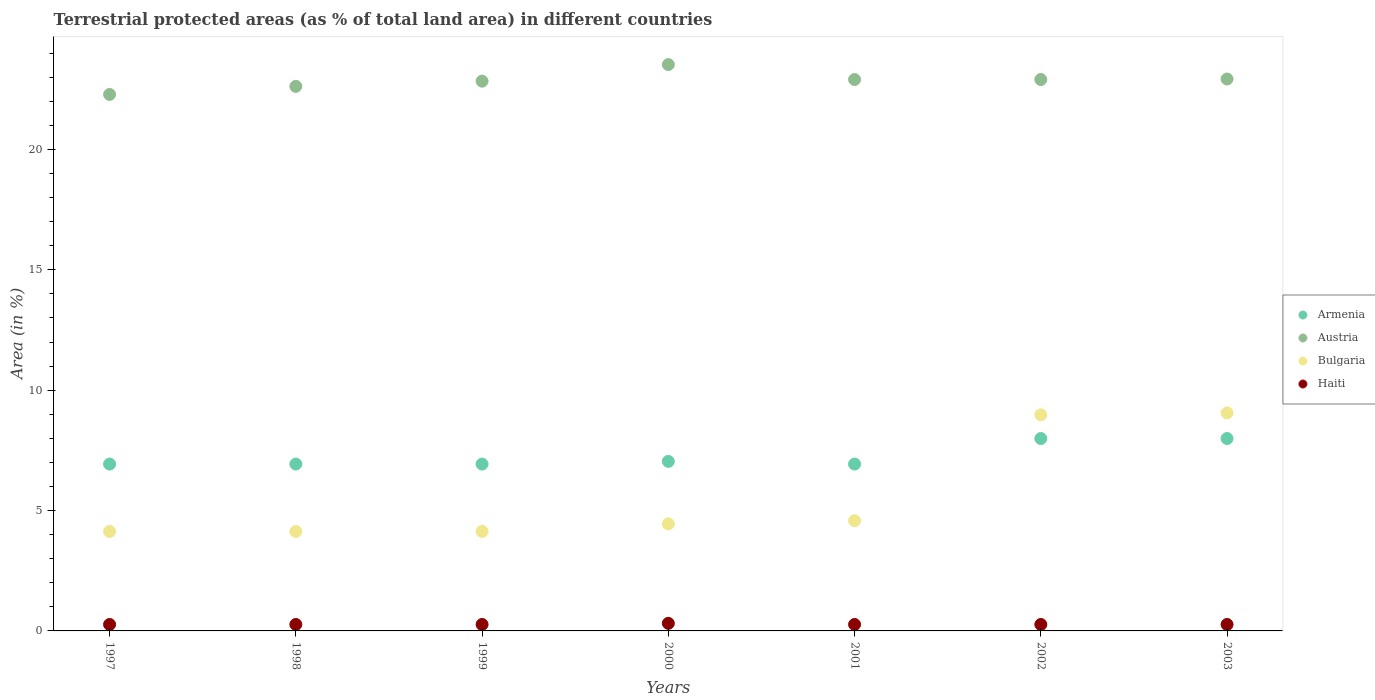What is the percentage of terrestrial protected land in Haiti in 1998?
Offer a very short reply. 0.27. Across all years, what is the maximum percentage of terrestrial protected land in Austria?
Provide a succinct answer. 23.52. Across all years, what is the minimum percentage of terrestrial protected land in Bulgaria?
Keep it short and to the point. 4.13. What is the total percentage of terrestrial protected land in Bulgaria in the graph?
Your answer should be very brief. 39.45. What is the difference between the percentage of terrestrial protected land in Bulgaria in 2000 and that in 2001?
Keep it short and to the point. -0.13. What is the difference between the percentage of terrestrial protected land in Bulgaria in 2002 and the percentage of terrestrial protected land in Armenia in 2000?
Offer a very short reply. 1.93. What is the average percentage of terrestrial protected land in Bulgaria per year?
Offer a very short reply. 5.64. In the year 2002, what is the difference between the percentage of terrestrial protected land in Haiti and percentage of terrestrial protected land in Bulgaria?
Offer a very short reply. -8.71. What is the ratio of the percentage of terrestrial protected land in Armenia in 2001 to that in 2003?
Keep it short and to the point. 0.87. What is the difference between the highest and the second highest percentage of terrestrial protected land in Bulgaria?
Make the answer very short. 0.08. What is the difference between the highest and the lowest percentage of terrestrial protected land in Armenia?
Make the answer very short. 1.06. Is it the case that in every year, the sum of the percentage of terrestrial protected land in Bulgaria and percentage of terrestrial protected land in Haiti  is greater than the sum of percentage of terrestrial protected land in Austria and percentage of terrestrial protected land in Armenia?
Keep it short and to the point. No. Does the percentage of terrestrial protected land in Bulgaria monotonically increase over the years?
Your answer should be very brief. No. Is the percentage of terrestrial protected land in Bulgaria strictly less than the percentage of terrestrial protected land in Austria over the years?
Your answer should be compact. Yes. How many years are there in the graph?
Your answer should be very brief. 7. Are the values on the major ticks of Y-axis written in scientific E-notation?
Give a very brief answer. No. Does the graph contain any zero values?
Provide a short and direct response. No. Does the graph contain grids?
Keep it short and to the point. No. Where does the legend appear in the graph?
Provide a succinct answer. Center right. What is the title of the graph?
Give a very brief answer. Terrestrial protected areas (as % of total land area) in different countries. What is the label or title of the Y-axis?
Offer a very short reply. Area (in %). What is the Area (in %) of Armenia in 1997?
Keep it short and to the point. 6.93. What is the Area (in %) of Austria in 1997?
Make the answer very short. 22.28. What is the Area (in %) of Bulgaria in 1997?
Your answer should be compact. 4.13. What is the Area (in %) in Haiti in 1997?
Make the answer very short. 0.27. What is the Area (in %) of Armenia in 1998?
Your answer should be very brief. 6.93. What is the Area (in %) in Austria in 1998?
Make the answer very short. 22.62. What is the Area (in %) of Bulgaria in 1998?
Your response must be concise. 4.13. What is the Area (in %) in Haiti in 1998?
Your response must be concise. 0.27. What is the Area (in %) of Armenia in 1999?
Your response must be concise. 6.93. What is the Area (in %) of Austria in 1999?
Your answer should be compact. 22.84. What is the Area (in %) of Bulgaria in 1999?
Your answer should be very brief. 4.13. What is the Area (in %) of Haiti in 1999?
Offer a very short reply. 0.27. What is the Area (in %) in Armenia in 2000?
Give a very brief answer. 7.04. What is the Area (in %) in Austria in 2000?
Give a very brief answer. 23.52. What is the Area (in %) of Bulgaria in 2000?
Give a very brief answer. 4.45. What is the Area (in %) in Haiti in 2000?
Your answer should be compact. 0.32. What is the Area (in %) in Armenia in 2001?
Provide a succinct answer. 6.93. What is the Area (in %) of Austria in 2001?
Keep it short and to the point. 22.9. What is the Area (in %) in Bulgaria in 2001?
Your answer should be compact. 4.58. What is the Area (in %) in Haiti in 2001?
Your answer should be compact. 0.27. What is the Area (in %) of Armenia in 2002?
Ensure brevity in your answer.  7.99. What is the Area (in %) of Austria in 2002?
Make the answer very short. 22.9. What is the Area (in %) in Bulgaria in 2002?
Your answer should be very brief. 8.97. What is the Area (in %) of Haiti in 2002?
Offer a terse response. 0.27. What is the Area (in %) of Armenia in 2003?
Give a very brief answer. 7.99. What is the Area (in %) of Austria in 2003?
Your answer should be very brief. 22.92. What is the Area (in %) of Bulgaria in 2003?
Your response must be concise. 9.06. What is the Area (in %) of Haiti in 2003?
Offer a terse response. 0.27. Across all years, what is the maximum Area (in %) of Armenia?
Keep it short and to the point. 7.99. Across all years, what is the maximum Area (in %) of Austria?
Give a very brief answer. 23.52. Across all years, what is the maximum Area (in %) of Bulgaria?
Provide a short and direct response. 9.06. Across all years, what is the maximum Area (in %) of Haiti?
Ensure brevity in your answer.  0.32. Across all years, what is the minimum Area (in %) of Armenia?
Your answer should be compact. 6.93. Across all years, what is the minimum Area (in %) in Austria?
Your answer should be very brief. 22.28. Across all years, what is the minimum Area (in %) in Bulgaria?
Provide a short and direct response. 4.13. Across all years, what is the minimum Area (in %) of Haiti?
Provide a succinct answer. 0.27. What is the total Area (in %) of Armenia in the graph?
Make the answer very short. 50.75. What is the total Area (in %) in Austria in the graph?
Offer a very short reply. 160. What is the total Area (in %) of Bulgaria in the graph?
Your answer should be very brief. 39.45. What is the total Area (in %) in Haiti in the graph?
Your answer should be very brief. 1.92. What is the difference between the Area (in %) in Armenia in 1997 and that in 1998?
Give a very brief answer. 0. What is the difference between the Area (in %) of Austria in 1997 and that in 1998?
Provide a short and direct response. -0.33. What is the difference between the Area (in %) in Haiti in 1997 and that in 1998?
Offer a very short reply. 0. What is the difference between the Area (in %) of Austria in 1997 and that in 1999?
Provide a succinct answer. -0.55. What is the difference between the Area (in %) in Bulgaria in 1997 and that in 1999?
Your answer should be very brief. -0. What is the difference between the Area (in %) of Haiti in 1997 and that in 1999?
Provide a succinct answer. 0. What is the difference between the Area (in %) in Armenia in 1997 and that in 2000?
Ensure brevity in your answer.  -0.11. What is the difference between the Area (in %) of Austria in 1997 and that in 2000?
Offer a terse response. -1.24. What is the difference between the Area (in %) of Bulgaria in 1997 and that in 2000?
Keep it short and to the point. -0.32. What is the difference between the Area (in %) of Haiti in 1997 and that in 2000?
Provide a succinct answer. -0.05. What is the difference between the Area (in %) in Austria in 1997 and that in 2001?
Offer a terse response. -0.62. What is the difference between the Area (in %) in Bulgaria in 1997 and that in 2001?
Offer a terse response. -0.45. What is the difference between the Area (in %) in Armenia in 1997 and that in 2002?
Your response must be concise. -1.06. What is the difference between the Area (in %) of Austria in 1997 and that in 2002?
Offer a very short reply. -0.62. What is the difference between the Area (in %) in Bulgaria in 1997 and that in 2002?
Your answer should be very brief. -4.84. What is the difference between the Area (in %) in Armenia in 1997 and that in 2003?
Offer a terse response. -1.06. What is the difference between the Area (in %) in Austria in 1997 and that in 2003?
Make the answer very short. -0.64. What is the difference between the Area (in %) in Bulgaria in 1997 and that in 2003?
Provide a short and direct response. -4.92. What is the difference between the Area (in %) in Armenia in 1998 and that in 1999?
Provide a short and direct response. 0. What is the difference between the Area (in %) of Austria in 1998 and that in 1999?
Your answer should be compact. -0.22. What is the difference between the Area (in %) in Bulgaria in 1998 and that in 1999?
Your answer should be very brief. -0. What is the difference between the Area (in %) in Haiti in 1998 and that in 1999?
Your response must be concise. 0. What is the difference between the Area (in %) of Armenia in 1998 and that in 2000?
Your answer should be very brief. -0.11. What is the difference between the Area (in %) of Austria in 1998 and that in 2000?
Ensure brevity in your answer.  -0.91. What is the difference between the Area (in %) of Bulgaria in 1998 and that in 2000?
Keep it short and to the point. -0.32. What is the difference between the Area (in %) in Haiti in 1998 and that in 2000?
Give a very brief answer. -0.05. What is the difference between the Area (in %) of Armenia in 1998 and that in 2001?
Provide a succinct answer. 0. What is the difference between the Area (in %) in Austria in 1998 and that in 2001?
Offer a terse response. -0.29. What is the difference between the Area (in %) in Bulgaria in 1998 and that in 2001?
Your answer should be very brief. -0.45. What is the difference between the Area (in %) of Armenia in 1998 and that in 2002?
Provide a succinct answer. -1.06. What is the difference between the Area (in %) of Austria in 1998 and that in 2002?
Keep it short and to the point. -0.29. What is the difference between the Area (in %) in Bulgaria in 1998 and that in 2002?
Give a very brief answer. -4.84. What is the difference between the Area (in %) in Haiti in 1998 and that in 2002?
Ensure brevity in your answer.  0. What is the difference between the Area (in %) of Armenia in 1998 and that in 2003?
Your answer should be compact. -1.06. What is the difference between the Area (in %) of Austria in 1998 and that in 2003?
Make the answer very short. -0.31. What is the difference between the Area (in %) in Bulgaria in 1998 and that in 2003?
Your response must be concise. -4.92. What is the difference between the Area (in %) of Haiti in 1998 and that in 2003?
Provide a succinct answer. 0. What is the difference between the Area (in %) of Armenia in 1999 and that in 2000?
Offer a very short reply. -0.11. What is the difference between the Area (in %) of Austria in 1999 and that in 2000?
Offer a terse response. -0.69. What is the difference between the Area (in %) of Bulgaria in 1999 and that in 2000?
Ensure brevity in your answer.  -0.31. What is the difference between the Area (in %) of Haiti in 1999 and that in 2000?
Make the answer very short. -0.05. What is the difference between the Area (in %) in Armenia in 1999 and that in 2001?
Give a very brief answer. 0. What is the difference between the Area (in %) in Austria in 1999 and that in 2001?
Ensure brevity in your answer.  -0.07. What is the difference between the Area (in %) of Bulgaria in 1999 and that in 2001?
Provide a short and direct response. -0.44. What is the difference between the Area (in %) in Haiti in 1999 and that in 2001?
Ensure brevity in your answer.  0. What is the difference between the Area (in %) of Armenia in 1999 and that in 2002?
Offer a terse response. -1.06. What is the difference between the Area (in %) of Austria in 1999 and that in 2002?
Keep it short and to the point. -0.07. What is the difference between the Area (in %) of Bulgaria in 1999 and that in 2002?
Ensure brevity in your answer.  -4.84. What is the difference between the Area (in %) of Haiti in 1999 and that in 2002?
Your answer should be very brief. 0. What is the difference between the Area (in %) of Armenia in 1999 and that in 2003?
Keep it short and to the point. -1.06. What is the difference between the Area (in %) in Austria in 1999 and that in 2003?
Keep it short and to the point. -0.09. What is the difference between the Area (in %) of Bulgaria in 1999 and that in 2003?
Keep it short and to the point. -4.92. What is the difference between the Area (in %) of Haiti in 1999 and that in 2003?
Your answer should be compact. 0. What is the difference between the Area (in %) in Armenia in 2000 and that in 2001?
Provide a short and direct response. 0.11. What is the difference between the Area (in %) in Austria in 2000 and that in 2001?
Give a very brief answer. 0.62. What is the difference between the Area (in %) in Bulgaria in 2000 and that in 2001?
Your response must be concise. -0.13. What is the difference between the Area (in %) in Haiti in 2000 and that in 2001?
Offer a terse response. 0.05. What is the difference between the Area (in %) in Armenia in 2000 and that in 2002?
Ensure brevity in your answer.  -0.95. What is the difference between the Area (in %) in Austria in 2000 and that in 2002?
Keep it short and to the point. 0.62. What is the difference between the Area (in %) in Bulgaria in 2000 and that in 2002?
Make the answer very short. -4.53. What is the difference between the Area (in %) of Haiti in 2000 and that in 2002?
Keep it short and to the point. 0.05. What is the difference between the Area (in %) in Armenia in 2000 and that in 2003?
Provide a short and direct response. -0.95. What is the difference between the Area (in %) in Austria in 2000 and that in 2003?
Give a very brief answer. 0.6. What is the difference between the Area (in %) of Bulgaria in 2000 and that in 2003?
Give a very brief answer. -4.61. What is the difference between the Area (in %) in Haiti in 2000 and that in 2003?
Give a very brief answer. 0.05. What is the difference between the Area (in %) of Armenia in 2001 and that in 2002?
Your answer should be compact. -1.06. What is the difference between the Area (in %) in Austria in 2001 and that in 2002?
Your response must be concise. -0. What is the difference between the Area (in %) of Bulgaria in 2001 and that in 2002?
Offer a very short reply. -4.4. What is the difference between the Area (in %) of Armenia in 2001 and that in 2003?
Your response must be concise. -1.06. What is the difference between the Area (in %) of Austria in 2001 and that in 2003?
Your answer should be compact. -0.02. What is the difference between the Area (in %) of Bulgaria in 2001 and that in 2003?
Keep it short and to the point. -4.48. What is the difference between the Area (in %) in Austria in 2002 and that in 2003?
Provide a succinct answer. -0.02. What is the difference between the Area (in %) of Bulgaria in 2002 and that in 2003?
Your answer should be very brief. -0.08. What is the difference between the Area (in %) in Armenia in 1997 and the Area (in %) in Austria in 1998?
Keep it short and to the point. -15.69. What is the difference between the Area (in %) of Armenia in 1997 and the Area (in %) of Bulgaria in 1998?
Keep it short and to the point. 2.8. What is the difference between the Area (in %) in Armenia in 1997 and the Area (in %) in Haiti in 1998?
Ensure brevity in your answer.  6.66. What is the difference between the Area (in %) of Austria in 1997 and the Area (in %) of Bulgaria in 1998?
Ensure brevity in your answer.  18.15. What is the difference between the Area (in %) in Austria in 1997 and the Area (in %) in Haiti in 1998?
Your answer should be compact. 22.02. What is the difference between the Area (in %) in Bulgaria in 1997 and the Area (in %) in Haiti in 1998?
Your answer should be very brief. 3.86. What is the difference between the Area (in %) of Armenia in 1997 and the Area (in %) of Austria in 1999?
Make the answer very short. -15.9. What is the difference between the Area (in %) of Armenia in 1997 and the Area (in %) of Bulgaria in 1999?
Keep it short and to the point. 2.8. What is the difference between the Area (in %) of Armenia in 1997 and the Area (in %) of Haiti in 1999?
Your answer should be very brief. 6.66. What is the difference between the Area (in %) in Austria in 1997 and the Area (in %) in Bulgaria in 1999?
Offer a very short reply. 18.15. What is the difference between the Area (in %) of Austria in 1997 and the Area (in %) of Haiti in 1999?
Provide a succinct answer. 22.02. What is the difference between the Area (in %) of Bulgaria in 1997 and the Area (in %) of Haiti in 1999?
Your answer should be very brief. 3.86. What is the difference between the Area (in %) of Armenia in 1997 and the Area (in %) of Austria in 2000?
Your answer should be very brief. -16.59. What is the difference between the Area (in %) in Armenia in 1997 and the Area (in %) in Bulgaria in 2000?
Your answer should be compact. 2.48. What is the difference between the Area (in %) in Armenia in 1997 and the Area (in %) in Haiti in 2000?
Ensure brevity in your answer.  6.62. What is the difference between the Area (in %) in Austria in 1997 and the Area (in %) in Bulgaria in 2000?
Give a very brief answer. 17.84. What is the difference between the Area (in %) of Austria in 1997 and the Area (in %) of Haiti in 2000?
Give a very brief answer. 21.97. What is the difference between the Area (in %) of Bulgaria in 1997 and the Area (in %) of Haiti in 2000?
Your answer should be very brief. 3.82. What is the difference between the Area (in %) in Armenia in 1997 and the Area (in %) in Austria in 2001?
Give a very brief answer. -15.97. What is the difference between the Area (in %) of Armenia in 1997 and the Area (in %) of Bulgaria in 2001?
Give a very brief answer. 2.35. What is the difference between the Area (in %) in Armenia in 1997 and the Area (in %) in Haiti in 2001?
Make the answer very short. 6.66. What is the difference between the Area (in %) in Austria in 1997 and the Area (in %) in Bulgaria in 2001?
Your answer should be compact. 17.71. What is the difference between the Area (in %) in Austria in 1997 and the Area (in %) in Haiti in 2001?
Provide a succinct answer. 22.02. What is the difference between the Area (in %) of Bulgaria in 1997 and the Area (in %) of Haiti in 2001?
Your answer should be compact. 3.86. What is the difference between the Area (in %) in Armenia in 1997 and the Area (in %) in Austria in 2002?
Offer a terse response. -15.97. What is the difference between the Area (in %) of Armenia in 1997 and the Area (in %) of Bulgaria in 2002?
Offer a terse response. -2.04. What is the difference between the Area (in %) in Armenia in 1997 and the Area (in %) in Haiti in 2002?
Your answer should be very brief. 6.66. What is the difference between the Area (in %) in Austria in 1997 and the Area (in %) in Bulgaria in 2002?
Provide a succinct answer. 13.31. What is the difference between the Area (in %) in Austria in 1997 and the Area (in %) in Haiti in 2002?
Ensure brevity in your answer.  22.02. What is the difference between the Area (in %) in Bulgaria in 1997 and the Area (in %) in Haiti in 2002?
Provide a succinct answer. 3.86. What is the difference between the Area (in %) of Armenia in 1997 and the Area (in %) of Austria in 2003?
Make the answer very short. -15.99. What is the difference between the Area (in %) of Armenia in 1997 and the Area (in %) of Bulgaria in 2003?
Your answer should be compact. -2.12. What is the difference between the Area (in %) of Armenia in 1997 and the Area (in %) of Haiti in 2003?
Ensure brevity in your answer.  6.66. What is the difference between the Area (in %) in Austria in 1997 and the Area (in %) in Bulgaria in 2003?
Make the answer very short. 13.23. What is the difference between the Area (in %) in Austria in 1997 and the Area (in %) in Haiti in 2003?
Provide a short and direct response. 22.02. What is the difference between the Area (in %) in Bulgaria in 1997 and the Area (in %) in Haiti in 2003?
Offer a terse response. 3.86. What is the difference between the Area (in %) of Armenia in 1998 and the Area (in %) of Austria in 1999?
Provide a succinct answer. -15.9. What is the difference between the Area (in %) in Armenia in 1998 and the Area (in %) in Bulgaria in 1999?
Give a very brief answer. 2.8. What is the difference between the Area (in %) in Armenia in 1998 and the Area (in %) in Haiti in 1999?
Offer a terse response. 6.66. What is the difference between the Area (in %) in Austria in 1998 and the Area (in %) in Bulgaria in 1999?
Make the answer very short. 18.49. What is the difference between the Area (in %) of Austria in 1998 and the Area (in %) of Haiti in 1999?
Offer a terse response. 22.35. What is the difference between the Area (in %) in Bulgaria in 1998 and the Area (in %) in Haiti in 1999?
Provide a short and direct response. 3.86. What is the difference between the Area (in %) in Armenia in 1998 and the Area (in %) in Austria in 2000?
Your answer should be compact. -16.59. What is the difference between the Area (in %) in Armenia in 1998 and the Area (in %) in Bulgaria in 2000?
Your response must be concise. 2.48. What is the difference between the Area (in %) in Armenia in 1998 and the Area (in %) in Haiti in 2000?
Offer a very short reply. 6.62. What is the difference between the Area (in %) in Austria in 1998 and the Area (in %) in Bulgaria in 2000?
Keep it short and to the point. 18.17. What is the difference between the Area (in %) of Austria in 1998 and the Area (in %) of Haiti in 2000?
Provide a short and direct response. 22.3. What is the difference between the Area (in %) of Bulgaria in 1998 and the Area (in %) of Haiti in 2000?
Give a very brief answer. 3.82. What is the difference between the Area (in %) in Armenia in 1998 and the Area (in %) in Austria in 2001?
Give a very brief answer. -15.97. What is the difference between the Area (in %) of Armenia in 1998 and the Area (in %) of Bulgaria in 2001?
Your response must be concise. 2.35. What is the difference between the Area (in %) of Armenia in 1998 and the Area (in %) of Haiti in 2001?
Your answer should be compact. 6.66. What is the difference between the Area (in %) of Austria in 1998 and the Area (in %) of Bulgaria in 2001?
Provide a succinct answer. 18.04. What is the difference between the Area (in %) in Austria in 1998 and the Area (in %) in Haiti in 2001?
Provide a short and direct response. 22.35. What is the difference between the Area (in %) in Bulgaria in 1998 and the Area (in %) in Haiti in 2001?
Offer a very short reply. 3.86. What is the difference between the Area (in %) of Armenia in 1998 and the Area (in %) of Austria in 2002?
Provide a succinct answer. -15.97. What is the difference between the Area (in %) in Armenia in 1998 and the Area (in %) in Bulgaria in 2002?
Give a very brief answer. -2.04. What is the difference between the Area (in %) in Armenia in 1998 and the Area (in %) in Haiti in 2002?
Offer a terse response. 6.66. What is the difference between the Area (in %) in Austria in 1998 and the Area (in %) in Bulgaria in 2002?
Your answer should be very brief. 13.64. What is the difference between the Area (in %) in Austria in 1998 and the Area (in %) in Haiti in 2002?
Offer a terse response. 22.35. What is the difference between the Area (in %) in Bulgaria in 1998 and the Area (in %) in Haiti in 2002?
Offer a terse response. 3.86. What is the difference between the Area (in %) of Armenia in 1998 and the Area (in %) of Austria in 2003?
Your response must be concise. -15.99. What is the difference between the Area (in %) in Armenia in 1998 and the Area (in %) in Bulgaria in 2003?
Offer a very short reply. -2.12. What is the difference between the Area (in %) in Armenia in 1998 and the Area (in %) in Haiti in 2003?
Offer a terse response. 6.66. What is the difference between the Area (in %) of Austria in 1998 and the Area (in %) of Bulgaria in 2003?
Your answer should be very brief. 13.56. What is the difference between the Area (in %) of Austria in 1998 and the Area (in %) of Haiti in 2003?
Your answer should be compact. 22.35. What is the difference between the Area (in %) of Bulgaria in 1998 and the Area (in %) of Haiti in 2003?
Ensure brevity in your answer.  3.86. What is the difference between the Area (in %) of Armenia in 1999 and the Area (in %) of Austria in 2000?
Your answer should be very brief. -16.59. What is the difference between the Area (in %) in Armenia in 1999 and the Area (in %) in Bulgaria in 2000?
Offer a very short reply. 2.48. What is the difference between the Area (in %) in Armenia in 1999 and the Area (in %) in Haiti in 2000?
Ensure brevity in your answer.  6.62. What is the difference between the Area (in %) in Austria in 1999 and the Area (in %) in Bulgaria in 2000?
Offer a terse response. 18.39. What is the difference between the Area (in %) in Austria in 1999 and the Area (in %) in Haiti in 2000?
Ensure brevity in your answer.  22.52. What is the difference between the Area (in %) in Bulgaria in 1999 and the Area (in %) in Haiti in 2000?
Offer a very short reply. 3.82. What is the difference between the Area (in %) of Armenia in 1999 and the Area (in %) of Austria in 2001?
Your answer should be compact. -15.97. What is the difference between the Area (in %) of Armenia in 1999 and the Area (in %) of Bulgaria in 2001?
Provide a succinct answer. 2.35. What is the difference between the Area (in %) of Armenia in 1999 and the Area (in %) of Haiti in 2001?
Offer a very short reply. 6.66. What is the difference between the Area (in %) in Austria in 1999 and the Area (in %) in Bulgaria in 2001?
Make the answer very short. 18.26. What is the difference between the Area (in %) in Austria in 1999 and the Area (in %) in Haiti in 2001?
Make the answer very short. 22.57. What is the difference between the Area (in %) of Bulgaria in 1999 and the Area (in %) of Haiti in 2001?
Your answer should be very brief. 3.86. What is the difference between the Area (in %) of Armenia in 1999 and the Area (in %) of Austria in 2002?
Keep it short and to the point. -15.97. What is the difference between the Area (in %) in Armenia in 1999 and the Area (in %) in Bulgaria in 2002?
Provide a short and direct response. -2.04. What is the difference between the Area (in %) of Armenia in 1999 and the Area (in %) of Haiti in 2002?
Keep it short and to the point. 6.66. What is the difference between the Area (in %) of Austria in 1999 and the Area (in %) of Bulgaria in 2002?
Provide a succinct answer. 13.86. What is the difference between the Area (in %) in Austria in 1999 and the Area (in %) in Haiti in 2002?
Keep it short and to the point. 22.57. What is the difference between the Area (in %) in Bulgaria in 1999 and the Area (in %) in Haiti in 2002?
Offer a terse response. 3.86. What is the difference between the Area (in %) in Armenia in 1999 and the Area (in %) in Austria in 2003?
Your answer should be compact. -15.99. What is the difference between the Area (in %) in Armenia in 1999 and the Area (in %) in Bulgaria in 2003?
Offer a very short reply. -2.12. What is the difference between the Area (in %) in Armenia in 1999 and the Area (in %) in Haiti in 2003?
Offer a terse response. 6.66. What is the difference between the Area (in %) in Austria in 1999 and the Area (in %) in Bulgaria in 2003?
Ensure brevity in your answer.  13.78. What is the difference between the Area (in %) in Austria in 1999 and the Area (in %) in Haiti in 2003?
Your answer should be very brief. 22.57. What is the difference between the Area (in %) of Bulgaria in 1999 and the Area (in %) of Haiti in 2003?
Offer a very short reply. 3.86. What is the difference between the Area (in %) in Armenia in 2000 and the Area (in %) in Austria in 2001?
Give a very brief answer. -15.86. What is the difference between the Area (in %) of Armenia in 2000 and the Area (in %) of Bulgaria in 2001?
Ensure brevity in your answer.  2.47. What is the difference between the Area (in %) of Armenia in 2000 and the Area (in %) of Haiti in 2001?
Your answer should be compact. 6.77. What is the difference between the Area (in %) in Austria in 2000 and the Area (in %) in Bulgaria in 2001?
Offer a terse response. 18.95. What is the difference between the Area (in %) of Austria in 2000 and the Area (in %) of Haiti in 2001?
Ensure brevity in your answer.  23.26. What is the difference between the Area (in %) in Bulgaria in 2000 and the Area (in %) in Haiti in 2001?
Provide a short and direct response. 4.18. What is the difference between the Area (in %) of Armenia in 2000 and the Area (in %) of Austria in 2002?
Your response must be concise. -15.86. What is the difference between the Area (in %) of Armenia in 2000 and the Area (in %) of Bulgaria in 2002?
Keep it short and to the point. -1.93. What is the difference between the Area (in %) in Armenia in 2000 and the Area (in %) in Haiti in 2002?
Offer a terse response. 6.77. What is the difference between the Area (in %) of Austria in 2000 and the Area (in %) of Bulgaria in 2002?
Keep it short and to the point. 14.55. What is the difference between the Area (in %) of Austria in 2000 and the Area (in %) of Haiti in 2002?
Make the answer very short. 23.26. What is the difference between the Area (in %) of Bulgaria in 2000 and the Area (in %) of Haiti in 2002?
Make the answer very short. 4.18. What is the difference between the Area (in %) of Armenia in 2000 and the Area (in %) of Austria in 2003?
Ensure brevity in your answer.  -15.88. What is the difference between the Area (in %) of Armenia in 2000 and the Area (in %) of Bulgaria in 2003?
Give a very brief answer. -2.01. What is the difference between the Area (in %) of Armenia in 2000 and the Area (in %) of Haiti in 2003?
Your response must be concise. 6.77. What is the difference between the Area (in %) in Austria in 2000 and the Area (in %) in Bulgaria in 2003?
Offer a terse response. 14.47. What is the difference between the Area (in %) of Austria in 2000 and the Area (in %) of Haiti in 2003?
Ensure brevity in your answer.  23.26. What is the difference between the Area (in %) of Bulgaria in 2000 and the Area (in %) of Haiti in 2003?
Your response must be concise. 4.18. What is the difference between the Area (in %) in Armenia in 2001 and the Area (in %) in Austria in 2002?
Provide a short and direct response. -15.97. What is the difference between the Area (in %) in Armenia in 2001 and the Area (in %) in Bulgaria in 2002?
Provide a short and direct response. -2.04. What is the difference between the Area (in %) in Armenia in 2001 and the Area (in %) in Haiti in 2002?
Provide a short and direct response. 6.66. What is the difference between the Area (in %) in Austria in 2001 and the Area (in %) in Bulgaria in 2002?
Your answer should be compact. 13.93. What is the difference between the Area (in %) in Austria in 2001 and the Area (in %) in Haiti in 2002?
Your answer should be very brief. 22.64. What is the difference between the Area (in %) in Bulgaria in 2001 and the Area (in %) in Haiti in 2002?
Your response must be concise. 4.31. What is the difference between the Area (in %) in Armenia in 2001 and the Area (in %) in Austria in 2003?
Offer a very short reply. -15.99. What is the difference between the Area (in %) of Armenia in 2001 and the Area (in %) of Bulgaria in 2003?
Give a very brief answer. -2.12. What is the difference between the Area (in %) in Armenia in 2001 and the Area (in %) in Haiti in 2003?
Make the answer very short. 6.66. What is the difference between the Area (in %) of Austria in 2001 and the Area (in %) of Bulgaria in 2003?
Ensure brevity in your answer.  13.85. What is the difference between the Area (in %) in Austria in 2001 and the Area (in %) in Haiti in 2003?
Offer a terse response. 22.64. What is the difference between the Area (in %) of Bulgaria in 2001 and the Area (in %) of Haiti in 2003?
Give a very brief answer. 4.31. What is the difference between the Area (in %) in Armenia in 2002 and the Area (in %) in Austria in 2003?
Your answer should be compact. -14.93. What is the difference between the Area (in %) of Armenia in 2002 and the Area (in %) of Bulgaria in 2003?
Offer a very short reply. -1.06. What is the difference between the Area (in %) in Armenia in 2002 and the Area (in %) in Haiti in 2003?
Offer a very short reply. 7.72. What is the difference between the Area (in %) in Austria in 2002 and the Area (in %) in Bulgaria in 2003?
Keep it short and to the point. 13.85. What is the difference between the Area (in %) of Austria in 2002 and the Area (in %) of Haiti in 2003?
Provide a short and direct response. 22.64. What is the difference between the Area (in %) in Bulgaria in 2002 and the Area (in %) in Haiti in 2003?
Ensure brevity in your answer.  8.71. What is the average Area (in %) of Armenia per year?
Keep it short and to the point. 7.25. What is the average Area (in %) in Austria per year?
Give a very brief answer. 22.86. What is the average Area (in %) of Bulgaria per year?
Make the answer very short. 5.64. What is the average Area (in %) in Haiti per year?
Give a very brief answer. 0.27. In the year 1997, what is the difference between the Area (in %) of Armenia and Area (in %) of Austria?
Make the answer very short. -15.35. In the year 1997, what is the difference between the Area (in %) in Armenia and Area (in %) in Bulgaria?
Your response must be concise. 2.8. In the year 1997, what is the difference between the Area (in %) in Armenia and Area (in %) in Haiti?
Ensure brevity in your answer.  6.66. In the year 1997, what is the difference between the Area (in %) in Austria and Area (in %) in Bulgaria?
Your answer should be compact. 18.15. In the year 1997, what is the difference between the Area (in %) of Austria and Area (in %) of Haiti?
Your answer should be compact. 22.02. In the year 1997, what is the difference between the Area (in %) of Bulgaria and Area (in %) of Haiti?
Offer a very short reply. 3.86. In the year 1998, what is the difference between the Area (in %) in Armenia and Area (in %) in Austria?
Keep it short and to the point. -15.69. In the year 1998, what is the difference between the Area (in %) of Armenia and Area (in %) of Bulgaria?
Give a very brief answer. 2.8. In the year 1998, what is the difference between the Area (in %) of Armenia and Area (in %) of Haiti?
Provide a succinct answer. 6.66. In the year 1998, what is the difference between the Area (in %) in Austria and Area (in %) in Bulgaria?
Provide a short and direct response. 18.49. In the year 1998, what is the difference between the Area (in %) in Austria and Area (in %) in Haiti?
Offer a terse response. 22.35. In the year 1998, what is the difference between the Area (in %) in Bulgaria and Area (in %) in Haiti?
Your answer should be very brief. 3.86. In the year 1999, what is the difference between the Area (in %) in Armenia and Area (in %) in Austria?
Your response must be concise. -15.9. In the year 1999, what is the difference between the Area (in %) in Armenia and Area (in %) in Bulgaria?
Offer a terse response. 2.8. In the year 1999, what is the difference between the Area (in %) of Armenia and Area (in %) of Haiti?
Provide a succinct answer. 6.66. In the year 1999, what is the difference between the Area (in %) in Austria and Area (in %) in Bulgaria?
Offer a terse response. 18.7. In the year 1999, what is the difference between the Area (in %) in Austria and Area (in %) in Haiti?
Offer a terse response. 22.57. In the year 1999, what is the difference between the Area (in %) of Bulgaria and Area (in %) of Haiti?
Your answer should be compact. 3.86. In the year 2000, what is the difference between the Area (in %) in Armenia and Area (in %) in Austria?
Make the answer very short. -16.48. In the year 2000, what is the difference between the Area (in %) in Armenia and Area (in %) in Bulgaria?
Ensure brevity in your answer.  2.6. In the year 2000, what is the difference between the Area (in %) of Armenia and Area (in %) of Haiti?
Provide a succinct answer. 6.73. In the year 2000, what is the difference between the Area (in %) of Austria and Area (in %) of Bulgaria?
Provide a short and direct response. 19.08. In the year 2000, what is the difference between the Area (in %) of Austria and Area (in %) of Haiti?
Provide a succinct answer. 23.21. In the year 2000, what is the difference between the Area (in %) of Bulgaria and Area (in %) of Haiti?
Offer a very short reply. 4.13. In the year 2001, what is the difference between the Area (in %) of Armenia and Area (in %) of Austria?
Your answer should be very brief. -15.97. In the year 2001, what is the difference between the Area (in %) in Armenia and Area (in %) in Bulgaria?
Provide a succinct answer. 2.35. In the year 2001, what is the difference between the Area (in %) in Armenia and Area (in %) in Haiti?
Your answer should be compact. 6.66. In the year 2001, what is the difference between the Area (in %) in Austria and Area (in %) in Bulgaria?
Provide a succinct answer. 18.33. In the year 2001, what is the difference between the Area (in %) in Austria and Area (in %) in Haiti?
Keep it short and to the point. 22.64. In the year 2001, what is the difference between the Area (in %) in Bulgaria and Area (in %) in Haiti?
Your response must be concise. 4.31. In the year 2002, what is the difference between the Area (in %) in Armenia and Area (in %) in Austria?
Your answer should be compact. -14.91. In the year 2002, what is the difference between the Area (in %) in Armenia and Area (in %) in Bulgaria?
Your answer should be compact. -0.98. In the year 2002, what is the difference between the Area (in %) of Armenia and Area (in %) of Haiti?
Ensure brevity in your answer.  7.72. In the year 2002, what is the difference between the Area (in %) of Austria and Area (in %) of Bulgaria?
Make the answer very short. 13.93. In the year 2002, what is the difference between the Area (in %) of Austria and Area (in %) of Haiti?
Your answer should be compact. 22.64. In the year 2002, what is the difference between the Area (in %) in Bulgaria and Area (in %) in Haiti?
Provide a succinct answer. 8.71. In the year 2003, what is the difference between the Area (in %) of Armenia and Area (in %) of Austria?
Provide a short and direct response. -14.93. In the year 2003, what is the difference between the Area (in %) in Armenia and Area (in %) in Bulgaria?
Your response must be concise. -1.06. In the year 2003, what is the difference between the Area (in %) of Armenia and Area (in %) of Haiti?
Offer a terse response. 7.72. In the year 2003, what is the difference between the Area (in %) of Austria and Area (in %) of Bulgaria?
Your answer should be compact. 13.87. In the year 2003, what is the difference between the Area (in %) of Austria and Area (in %) of Haiti?
Make the answer very short. 22.66. In the year 2003, what is the difference between the Area (in %) in Bulgaria and Area (in %) in Haiti?
Keep it short and to the point. 8.79. What is the ratio of the Area (in %) in Armenia in 1997 to that in 1998?
Offer a very short reply. 1. What is the ratio of the Area (in %) in Austria in 1997 to that in 1998?
Provide a short and direct response. 0.99. What is the ratio of the Area (in %) in Armenia in 1997 to that in 1999?
Ensure brevity in your answer.  1. What is the ratio of the Area (in %) of Austria in 1997 to that in 1999?
Your answer should be compact. 0.98. What is the ratio of the Area (in %) in Bulgaria in 1997 to that in 1999?
Your answer should be very brief. 1. What is the ratio of the Area (in %) in Armenia in 1997 to that in 2000?
Make the answer very short. 0.98. What is the ratio of the Area (in %) in Austria in 1997 to that in 2000?
Give a very brief answer. 0.95. What is the ratio of the Area (in %) in Bulgaria in 1997 to that in 2000?
Offer a very short reply. 0.93. What is the ratio of the Area (in %) of Haiti in 1997 to that in 2000?
Give a very brief answer. 0.85. What is the ratio of the Area (in %) in Armenia in 1997 to that in 2001?
Your answer should be compact. 1. What is the ratio of the Area (in %) of Austria in 1997 to that in 2001?
Give a very brief answer. 0.97. What is the ratio of the Area (in %) of Bulgaria in 1997 to that in 2001?
Keep it short and to the point. 0.9. What is the ratio of the Area (in %) of Haiti in 1997 to that in 2001?
Ensure brevity in your answer.  1. What is the ratio of the Area (in %) in Armenia in 1997 to that in 2002?
Your response must be concise. 0.87. What is the ratio of the Area (in %) of Austria in 1997 to that in 2002?
Your response must be concise. 0.97. What is the ratio of the Area (in %) of Bulgaria in 1997 to that in 2002?
Offer a terse response. 0.46. What is the ratio of the Area (in %) in Haiti in 1997 to that in 2002?
Ensure brevity in your answer.  1. What is the ratio of the Area (in %) in Armenia in 1997 to that in 2003?
Make the answer very short. 0.87. What is the ratio of the Area (in %) in Austria in 1997 to that in 2003?
Make the answer very short. 0.97. What is the ratio of the Area (in %) in Bulgaria in 1997 to that in 2003?
Make the answer very short. 0.46. What is the ratio of the Area (in %) of Austria in 1998 to that in 1999?
Ensure brevity in your answer.  0.99. What is the ratio of the Area (in %) in Bulgaria in 1998 to that in 1999?
Make the answer very short. 1. What is the ratio of the Area (in %) in Armenia in 1998 to that in 2000?
Ensure brevity in your answer.  0.98. What is the ratio of the Area (in %) of Austria in 1998 to that in 2000?
Provide a short and direct response. 0.96. What is the ratio of the Area (in %) in Bulgaria in 1998 to that in 2000?
Provide a short and direct response. 0.93. What is the ratio of the Area (in %) in Haiti in 1998 to that in 2000?
Give a very brief answer. 0.85. What is the ratio of the Area (in %) of Armenia in 1998 to that in 2001?
Your answer should be very brief. 1. What is the ratio of the Area (in %) of Austria in 1998 to that in 2001?
Offer a very short reply. 0.99. What is the ratio of the Area (in %) in Bulgaria in 1998 to that in 2001?
Provide a short and direct response. 0.9. What is the ratio of the Area (in %) in Armenia in 1998 to that in 2002?
Your response must be concise. 0.87. What is the ratio of the Area (in %) of Austria in 1998 to that in 2002?
Offer a very short reply. 0.99. What is the ratio of the Area (in %) of Bulgaria in 1998 to that in 2002?
Ensure brevity in your answer.  0.46. What is the ratio of the Area (in %) of Armenia in 1998 to that in 2003?
Provide a short and direct response. 0.87. What is the ratio of the Area (in %) of Austria in 1998 to that in 2003?
Provide a succinct answer. 0.99. What is the ratio of the Area (in %) of Bulgaria in 1998 to that in 2003?
Provide a short and direct response. 0.46. What is the ratio of the Area (in %) in Haiti in 1998 to that in 2003?
Offer a very short reply. 1. What is the ratio of the Area (in %) in Armenia in 1999 to that in 2000?
Offer a terse response. 0.98. What is the ratio of the Area (in %) in Austria in 1999 to that in 2000?
Your answer should be very brief. 0.97. What is the ratio of the Area (in %) in Bulgaria in 1999 to that in 2000?
Provide a short and direct response. 0.93. What is the ratio of the Area (in %) of Haiti in 1999 to that in 2000?
Offer a very short reply. 0.85. What is the ratio of the Area (in %) in Armenia in 1999 to that in 2001?
Your answer should be very brief. 1. What is the ratio of the Area (in %) in Bulgaria in 1999 to that in 2001?
Offer a terse response. 0.9. What is the ratio of the Area (in %) in Haiti in 1999 to that in 2001?
Make the answer very short. 1. What is the ratio of the Area (in %) of Armenia in 1999 to that in 2002?
Provide a succinct answer. 0.87. What is the ratio of the Area (in %) of Austria in 1999 to that in 2002?
Keep it short and to the point. 1. What is the ratio of the Area (in %) in Bulgaria in 1999 to that in 2002?
Your response must be concise. 0.46. What is the ratio of the Area (in %) in Armenia in 1999 to that in 2003?
Give a very brief answer. 0.87. What is the ratio of the Area (in %) of Austria in 1999 to that in 2003?
Ensure brevity in your answer.  1. What is the ratio of the Area (in %) in Bulgaria in 1999 to that in 2003?
Your answer should be very brief. 0.46. What is the ratio of the Area (in %) of Austria in 2000 to that in 2001?
Offer a very short reply. 1.03. What is the ratio of the Area (in %) in Bulgaria in 2000 to that in 2001?
Keep it short and to the point. 0.97. What is the ratio of the Area (in %) of Haiti in 2000 to that in 2001?
Make the answer very short. 1.18. What is the ratio of the Area (in %) in Armenia in 2000 to that in 2002?
Keep it short and to the point. 0.88. What is the ratio of the Area (in %) of Austria in 2000 to that in 2002?
Your answer should be very brief. 1.03. What is the ratio of the Area (in %) of Bulgaria in 2000 to that in 2002?
Give a very brief answer. 0.5. What is the ratio of the Area (in %) in Haiti in 2000 to that in 2002?
Offer a very short reply. 1.18. What is the ratio of the Area (in %) in Armenia in 2000 to that in 2003?
Make the answer very short. 0.88. What is the ratio of the Area (in %) of Austria in 2000 to that in 2003?
Make the answer very short. 1.03. What is the ratio of the Area (in %) of Bulgaria in 2000 to that in 2003?
Offer a terse response. 0.49. What is the ratio of the Area (in %) of Haiti in 2000 to that in 2003?
Make the answer very short. 1.18. What is the ratio of the Area (in %) in Armenia in 2001 to that in 2002?
Provide a succinct answer. 0.87. What is the ratio of the Area (in %) of Bulgaria in 2001 to that in 2002?
Offer a very short reply. 0.51. What is the ratio of the Area (in %) in Haiti in 2001 to that in 2002?
Your answer should be compact. 1. What is the ratio of the Area (in %) in Armenia in 2001 to that in 2003?
Offer a very short reply. 0.87. What is the ratio of the Area (in %) in Austria in 2001 to that in 2003?
Your answer should be very brief. 1. What is the ratio of the Area (in %) of Bulgaria in 2001 to that in 2003?
Your response must be concise. 0.51. What is the ratio of the Area (in %) in Haiti in 2001 to that in 2003?
Keep it short and to the point. 1. What is the difference between the highest and the second highest Area (in %) of Armenia?
Offer a very short reply. 0. What is the difference between the highest and the second highest Area (in %) of Austria?
Make the answer very short. 0.6. What is the difference between the highest and the second highest Area (in %) in Bulgaria?
Give a very brief answer. 0.08. What is the difference between the highest and the second highest Area (in %) in Haiti?
Your answer should be very brief. 0.05. What is the difference between the highest and the lowest Area (in %) in Armenia?
Offer a very short reply. 1.06. What is the difference between the highest and the lowest Area (in %) of Austria?
Your answer should be compact. 1.24. What is the difference between the highest and the lowest Area (in %) in Bulgaria?
Your response must be concise. 4.92. What is the difference between the highest and the lowest Area (in %) of Haiti?
Offer a very short reply. 0.05. 